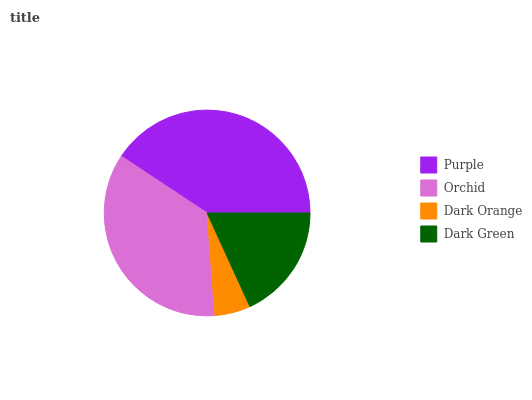Is Dark Orange the minimum?
Answer yes or no. Yes. Is Purple the maximum?
Answer yes or no. Yes. Is Orchid the minimum?
Answer yes or no. No. Is Orchid the maximum?
Answer yes or no. No. Is Purple greater than Orchid?
Answer yes or no. Yes. Is Orchid less than Purple?
Answer yes or no. Yes. Is Orchid greater than Purple?
Answer yes or no. No. Is Purple less than Orchid?
Answer yes or no. No. Is Orchid the high median?
Answer yes or no. Yes. Is Dark Green the low median?
Answer yes or no. Yes. Is Dark Orange the high median?
Answer yes or no. No. Is Purple the low median?
Answer yes or no. No. 